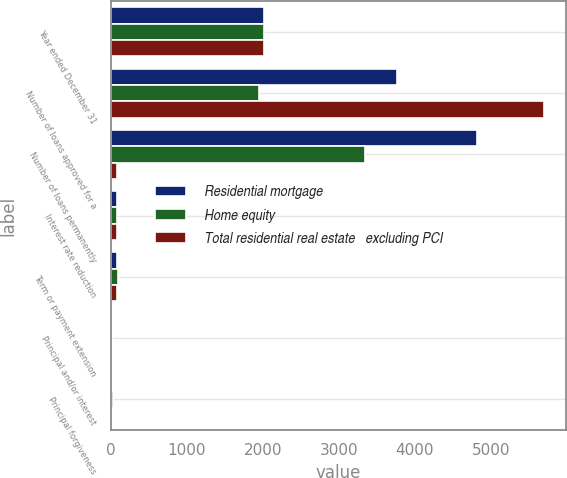Convert chart to OTSL. <chart><loc_0><loc_0><loc_500><loc_500><stacked_bar_chart><ecel><fcel>Year ended December 31<fcel>Number of loans approved for a<fcel>Number of loans permanently<fcel>Interest rate reduction<fcel>Term or payment extension<fcel>Principal and/or interest<fcel>Principal forgiveness<nl><fcel>Residential mortgage<fcel>2016<fcel>3760<fcel>4824<fcel>75<fcel>83<fcel>19<fcel>9<nl><fcel>Home equity<fcel>2016<fcel>1945<fcel>3338<fcel>76<fcel>90<fcel>16<fcel>26<nl><fcel>Total residential real estate   excluding PCI<fcel>2016<fcel>5705<fcel>84.5<fcel>76<fcel>86<fcel>18<fcel>16<nl></chart> 